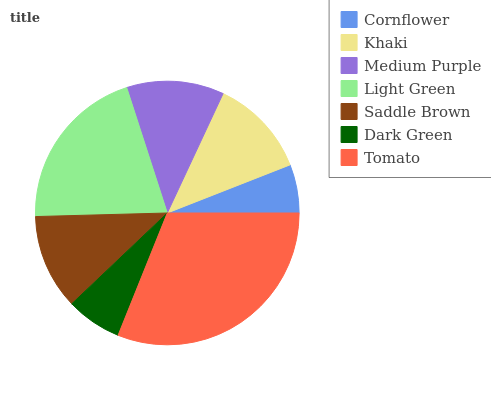Is Cornflower the minimum?
Answer yes or no. Yes. Is Tomato the maximum?
Answer yes or no. Yes. Is Khaki the minimum?
Answer yes or no. No. Is Khaki the maximum?
Answer yes or no. No. Is Khaki greater than Cornflower?
Answer yes or no. Yes. Is Cornflower less than Khaki?
Answer yes or no. Yes. Is Cornflower greater than Khaki?
Answer yes or no. No. Is Khaki less than Cornflower?
Answer yes or no. No. Is Medium Purple the high median?
Answer yes or no. Yes. Is Medium Purple the low median?
Answer yes or no. Yes. Is Cornflower the high median?
Answer yes or no. No. Is Khaki the low median?
Answer yes or no. No. 